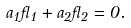<formula> <loc_0><loc_0><loc_500><loc_500>a _ { 1 } \gamma _ { 1 } + a _ { 2 } \gamma _ { 2 } = 0 .</formula> 